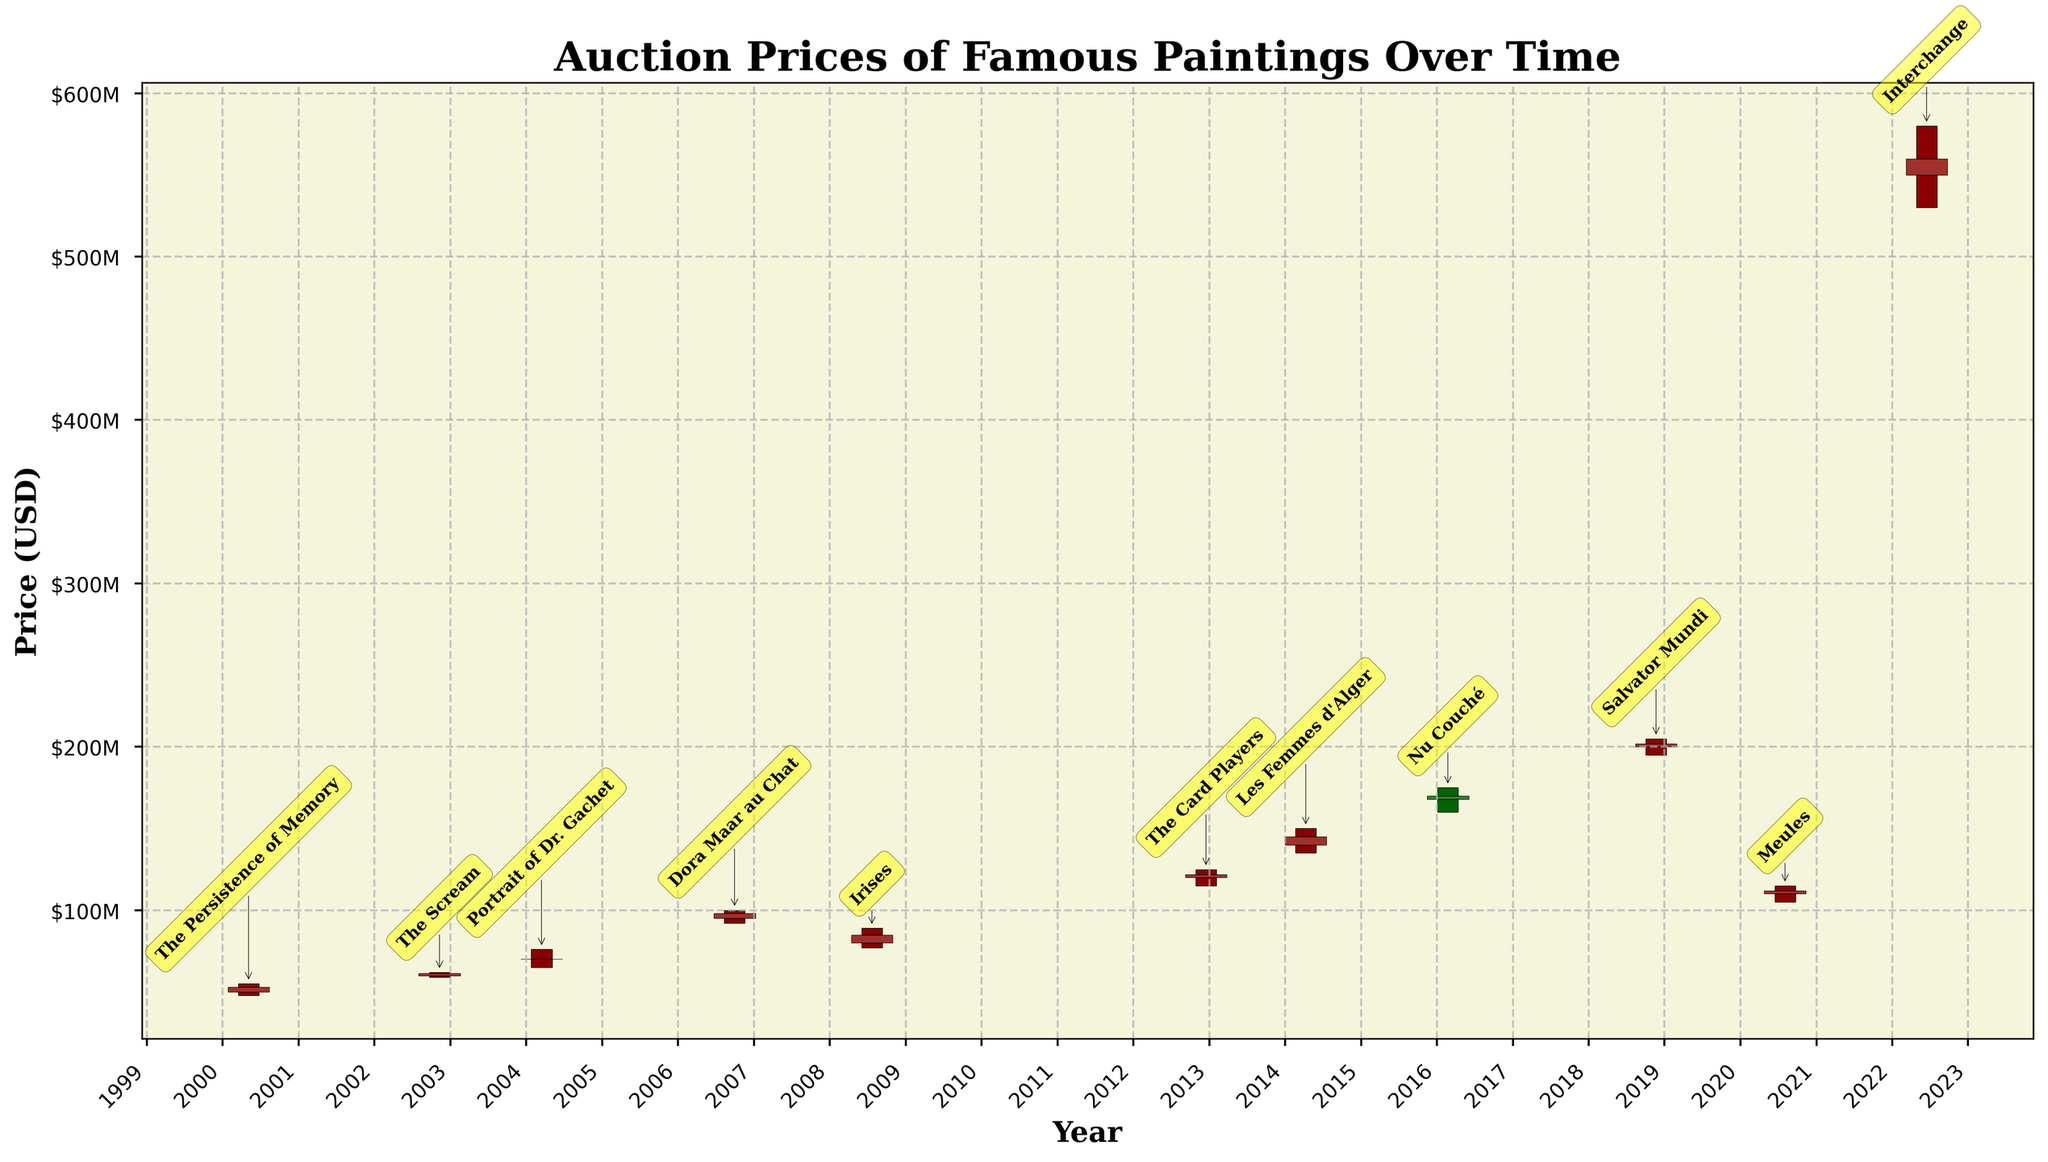What is the highest auction price recorded in the plot? The highest auction price is shown by the top of the highest candlestick, which reached $580 million. This can be found in the annotated label "Interchange".
Answer: $580 million Which painting had the largest volume of transactions? To identify the painting with the largest volume, we look at the "Volume" labels on the candlesticks. The painting "Meules" by Claude Monet, with 8 transactions, has the highest volume.
Answer: Meules What is the time range covered by the auction prices? The x-axis shows the years, starting from 2000 and ending in 2022. This means the time range spans 22 years.
Answer: 22 years How does the closing price of "The Scream" compare to its opening price? For "The Scream," the candlestick shows that the closing price is $61.5 million, which is higher than the opening price of $60 million.
Answer: Higher What is the average closing price of all paintings shown? To calculate the average, sum all the closing prices and divide by the number of paintings. Sum: $53m + $61.5m + $70m + $98m + $85m + $122m + $145m + $168m + $202m + $112m + $560m = $1676.5m. Divide by 11 paintings: $1676.5m / 11 ≈ $152.4m.
Answer: $152.4 million Which year recorded the largest increase in price from open to close? The largest increase is seen in 2018 with "Salvator Mundi" by Leonardo da Vinci. The open price was $200 million and the close price was $202 million, indicating a $2 million increase.
Answer: 2018 What colors represent increased and decreased prices on the plot? Increased prices are represented by dark red candlesticks; decreased prices are shown with dark green candlesticks.
Answer: Dark red and dark green How does the auction price trend change over the years? By examining the upper and lower bounds of the candlestick bars, the auction prices generally trend upwards over the years, with significant spikes in 2012 and 2022.
Answer: Upwards Which painting experienced the highest high price in the years surveyed? The highest high price is annotated at the topmost point, indicating "Interchange" by Willem de Kooning in 2022, with a high of $580 million.
Answer: Interchange How many paintings experienced a drop in their closing price compared to their opening price? By counting the dark green candlesticks, which show drops in closing prices, there are 3 paintings: "Portrait of Dr. Gachet," "Nu Couché," and "Meules."
Answer: 3 